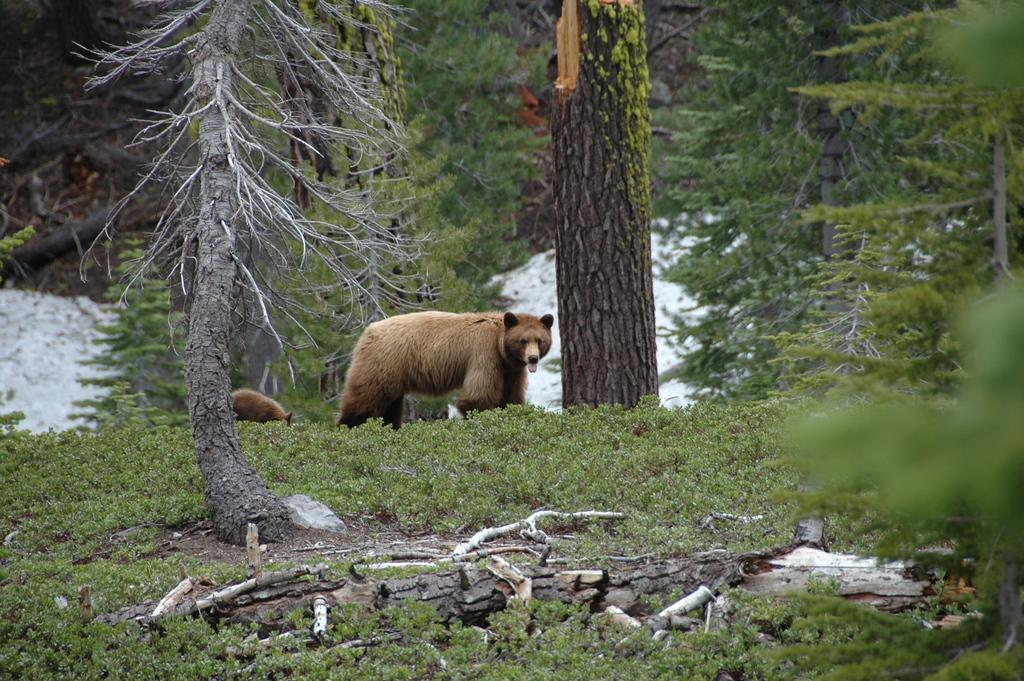Describe this image in one or two sentences. At the bottom of the image there is grass on the ground and also there is a tree trunk on the ground. There are two bears standing on the grass. And in the background there are many trees. 